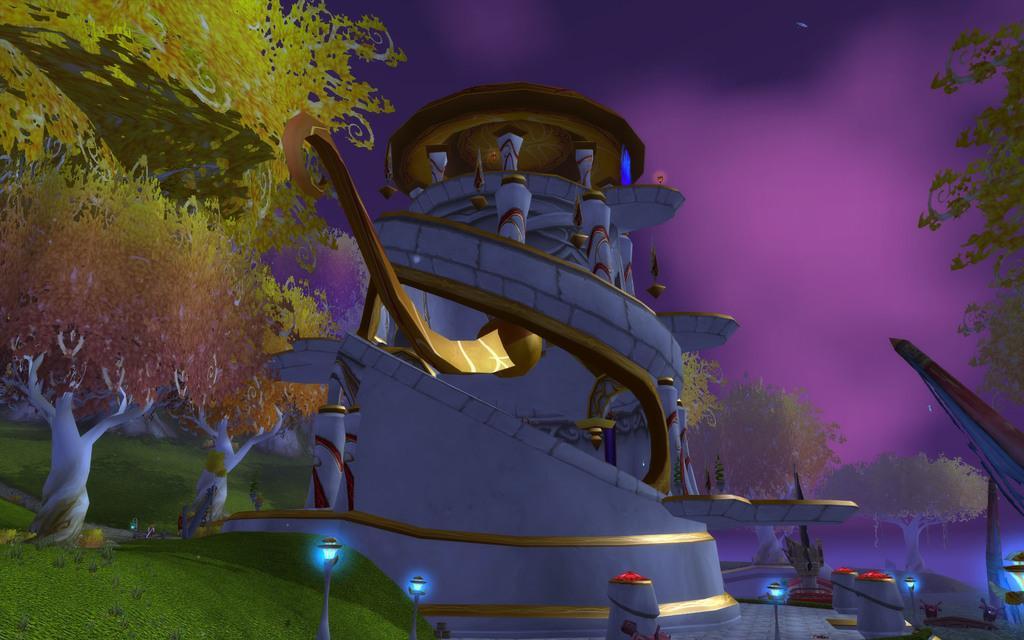Describe this image in one or two sentences. In the image we can see there is an animation picture in which there is a building and there are trees. There are street light poles on the ground and the ground is covered with grass. 